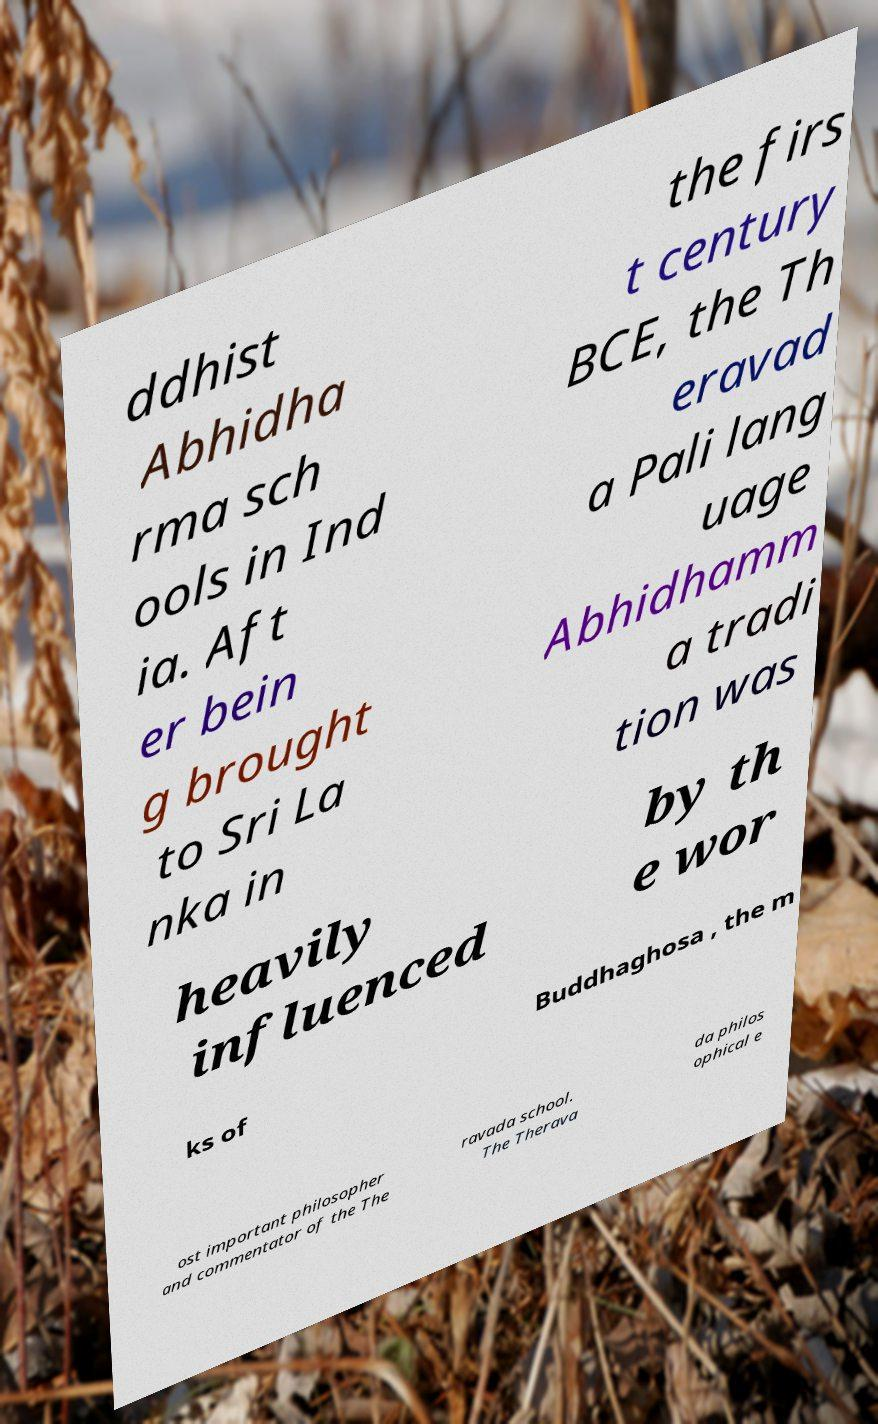Could you assist in decoding the text presented in this image and type it out clearly? ddhist Abhidha rma sch ools in Ind ia. Aft er bein g brought to Sri La nka in the firs t century BCE, the Th eravad a Pali lang uage Abhidhamm a tradi tion was heavily influenced by th e wor ks of Buddhaghosa , the m ost important philosopher and commentator of the The ravada school. The Therava da philos ophical e 